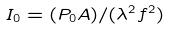Convert formula to latex. <formula><loc_0><loc_0><loc_500><loc_500>I _ { 0 } = ( P _ { 0 } A ) / ( \lambda ^ { 2 } f ^ { 2 } )</formula> 